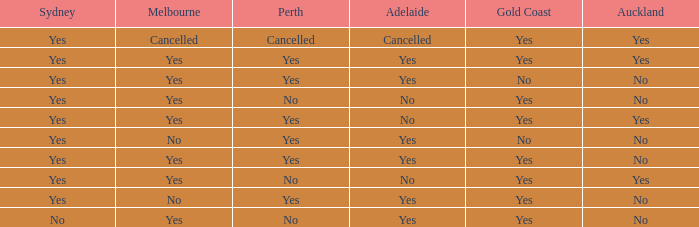What is the melbourne with a no- precious coast? Yes, No. Would you mind parsing the complete table? {'header': ['Sydney', 'Melbourne', 'Perth', 'Adelaide', 'Gold Coast', 'Auckland'], 'rows': [['Yes', 'Cancelled', 'Cancelled', 'Cancelled', 'Yes', 'Yes'], ['Yes', 'Yes', 'Yes', 'Yes', 'Yes', 'Yes'], ['Yes', 'Yes', 'Yes', 'Yes', 'No', 'No'], ['Yes', 'Yes', 'No', 'No', 'Yes', 'No'], ['Yes', 'Yes', 'Yes', 'No', 'Yes', 'Yes'], ['Yes', 'No', 'Yes', 'Yes', 'No', 'No'], ['Yes', 'Yes', 'Yes', 'Yes', 'Yes', 'No'], ['Yes', 'Yes', 'No', 'No', 'Yes', 'Yes'], ['Yes', 'No', 'Yes', 'Yes', 'Yes', 'No'], ['No', 'Yes', 'No', 'Yes', 'Yes', 'No']]} 